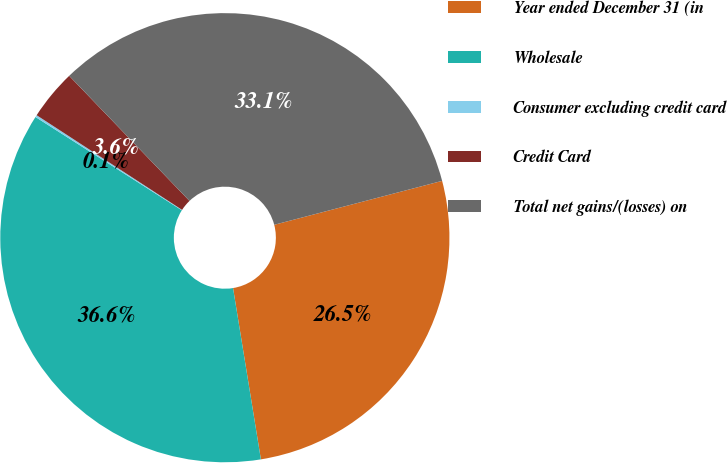Convert chart. <chart><loc_0><loc_0><loc_500><loc_500><pie_chart><fcel>Year ended December 31 (in<fcel>Wholesale<fcel>Consumer excluding credit card<fcel>Credit Card<fcel>Total net gains/(losses) on<nl><fcel>26.51%<fcel>36.6%<fcel>0.15%<fcel>3.63%<fcel>33.12%<nl></chart> 